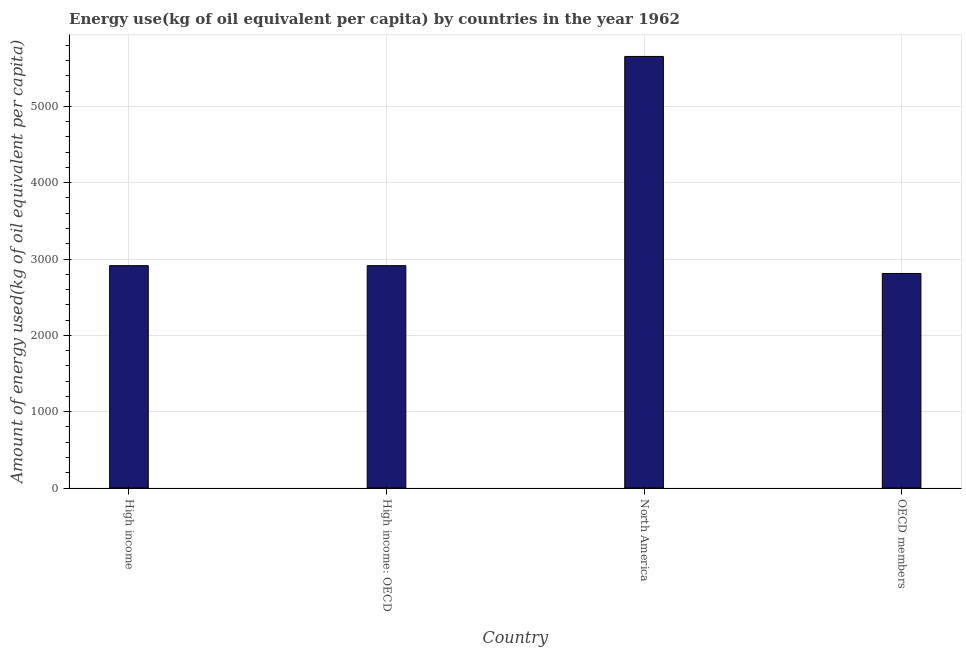What is the title of the graph?
Offer a terse response. Energy use(kg of oil equivalent per capita) by countries in the year 1962. What is the label or title of the Y-axis?
Keep it short and to the point. Amount of energy used(kg of oil equivalent per capita). What is the amount of energy used in North America?
Provide a short and direct response. 5654.54. Across all countries, what is the maximum amount of energy used?
Your response must be concise. 5654.54. Across all countries, what is the minimum amount of energy used?
Your response must be concise. 2810.85. What is the sum of the amount of energy used?
Keep it short and to the point. 1.43e+04. What is the difference between the amount of energy used in High income: OECD and OECD members?
Make the answer very short. 102.57. What is the average amount of energy used per country?
Give a very brief answer. 3573.06. What is the median amount of energy used?
Ensure brevity in your answer.  2913.43. What is the ratio of the amount of energy used in High income: OECD to that in OECD members?
Your answer should be very brief. 1.04. Is the difference between the amount of energy used in High income: OECD and OECD members greater than the difference between any two countries?
Offer a very short reply. No. What is the difference between the highest and the second highest amount of energy used?
Keep it short and to the point. 2741.12. Is the sum of the amount of energy used in High income and North America greater than the maximum amount of energy used across all countries?
Offer a terse response. Yes. What is the difference between the highest and the lowest amount of energy used?
Offer a terse response. 2843.69. Are the values on the major ticks of Y-axis written in scientific E-notation?
Provide a succinct answer. No. What is the Amount of energy used(kg of oil equivalent per capita) in High income?
Offer a very short reply. 2913.43. What is the Amount of energy used(kg of oil equivalent per capita) of High income: OECD?
Your response must be concise. 2913.43. What is the Amount of energy used(kg of oil equivalent per capita) in North America?
Provide a succinct answer. 5654.54. What is the Amount of energy used(kg of oil equivalent per capita) in OECD members?
Provide a succinct answer. 2810.85. What is the difference between the Amount of energy used(kg of oil equivalent per capita) in High income and High income: OECD?
Ensure brevity in your answer.  0. What is the difference between the Amount of energy used(kg of oil equivalent per capita) in High income and North America?
Provide a short and direct response. -2741.12. What is the difference between the Amount of energy used(kg of oil equivalent per capita) in High income and OECD members?
Your answer should be compact. 102.57. What is the difference between the Amount of energy used(kg of oil equivalent per capita) in High income: OECD and North America?
Make the answer very short. -2741.12. What is the difference between the Amount of energy used(kg of oil equivalent per capita) in High income: OECD and OECD members?
Ensure brevity in your answer.  102.57. What is the difference between the Amount of energy used(kg of oil equivalent per capita) in North America and OECD members?
Provide a short and direct response. 2843.69. What is the ratio of the Amount of energy used(kg of oil equivalent per capita) in High income to that in High income: OECD?
Provide a succinct answer. 1. What is the ratio of the Amount of energy used(kg of oil equivalent per capita) in High income to that in North America?
Your response must be concise. 0.52. What is the ratio of the Amount of energy used(kg of oil equivalent per capita) in High income to that in OECD members?
Offer a terse response. 1.04. What is the ratio of the Amount of energy used(kg of oil equivalent per capita) in High income: OECD to that in North America?
Ensure brevity in your answer.  0.52. What is the ratio of the Amount of energy used(kg of oil equivalent per capita) in High income: OECD to that in OECD members?
Your response must be concise. 1.04. What is the ratio of the Amount of energy used(kg of oil equivalent per capita) in North America to that in OECD members?
Make the answer very short. 2.01. 